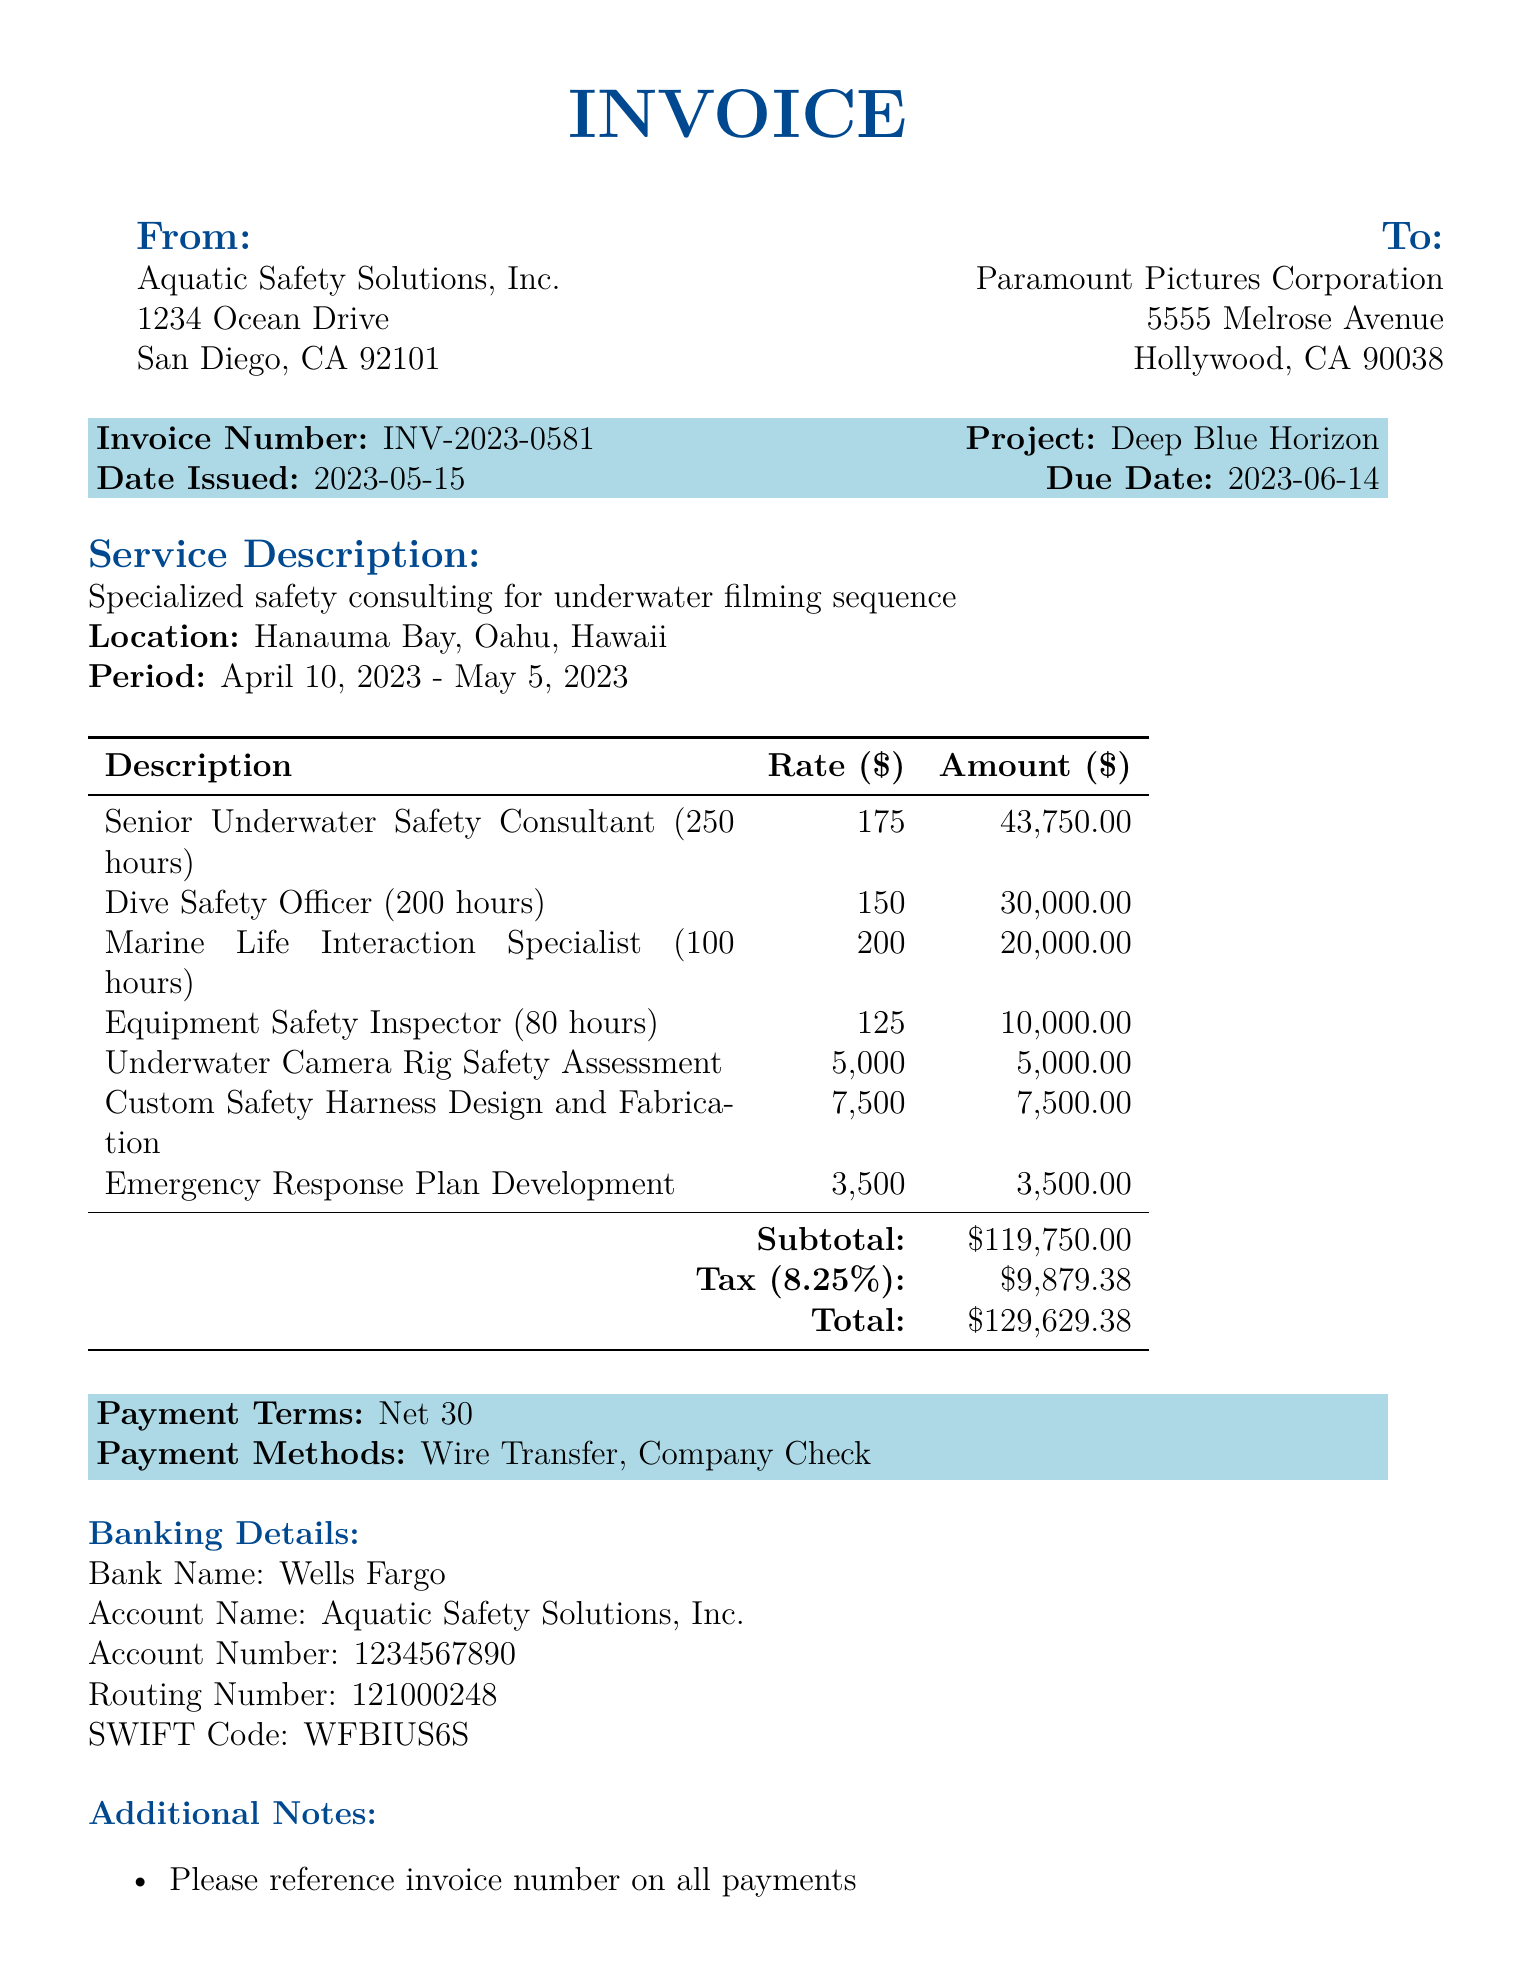what is the invoice number? The invoice number is specifically stated in the document as INV-2023-0581.
Answer: INV-2023-0581 who is the service provider? The service provider's name can be found in the document as Aquatic Safety Solutions, Inc.
Answer: Aquatic Safety Solutions, Inc what is the total amount due? The total amount due is the final balance indicated in the document, which includes subtotal and tax.
Answer: 129629.38 what is the consultation period? The consultation period specifies the duration of the services rendered, found as April 10, 2023 - May 5, 2023.
Answer: April 10, 2023 - May 5, 2023 how many hours did the Senior Underwater Safety Consultant work? The document states the Senior Underwater Safety Consultant worked for 250 hours.
Answer: 250 hours what is the tax rate applied? The tax rate that is applied to the subtotal in the document is mentioned as 8.25%.
Answer: 8.25% what is the payment method listed in the document? The payment methods are specified in the document as Wire Transfer and Company Check.
Answer: Wire Transfer, Company Check who is the contact person for this invoice? The document lists Sarah Johnson as the contact person, along with her position and contact details.
Answer: Sarah Johnson what is the due date for payment? The due date is explicitly stated in the invoice as June 14, 2023.
Answer: June 14, 2023 what happens if payment is received late? The document mentions that a 2% late fee will be applied for late payments.
Answer: A 2% late fee 